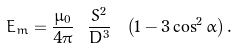Convert formula to latex. <formula><loc_0><loc_0><loc_500><loc_500>E _ { m } = \frac { \mu _ { 0 } } { 4 \pi } \ \frac { S ^ { 2 } } { D ^ { 3 } } \ \left ( 1 - 3 \cos ^ { 2 } \alpha \right ) .</formula> 